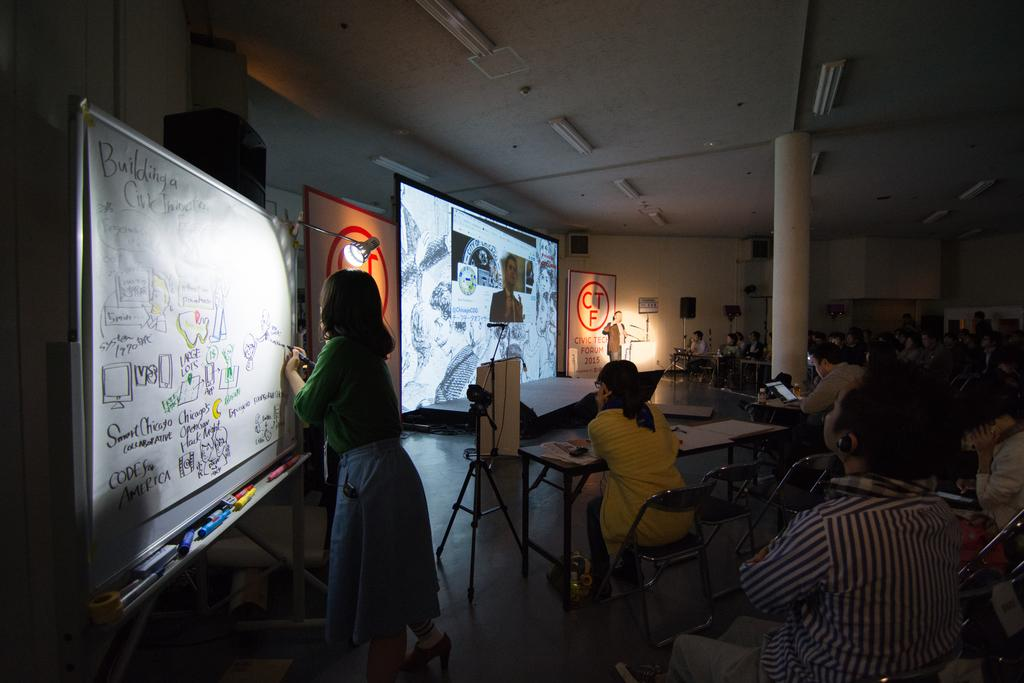How many screens are visible in the image? There are two screens in the image. What are the people in the image doing? The people in the image are sitting on chairs. What object is located in the front of the image? There is a table in the front of the image. What type of oil can be seen on the road in the image? There is no road or oil present in the image. What might surprise the people sitting on chairs in the image? It is impossible to determine what might surprise the people sitting on chairs in the image based on the provided facts. 